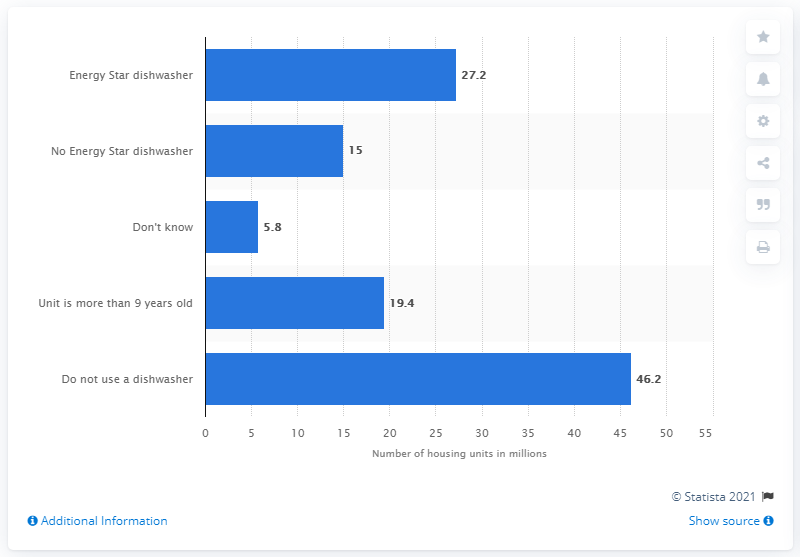Give some essential details in this illustration. According to the data, approximately 15% of housing units do not use an Energy Star qualified dishwasher. 